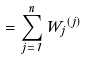<formula> <loc_0><loc_0><loc_500><loc_500>\Phi = \sum _ { j = 1 } ^ { n } W _ { j } \Phi ^ { ( j ) }</formula> 